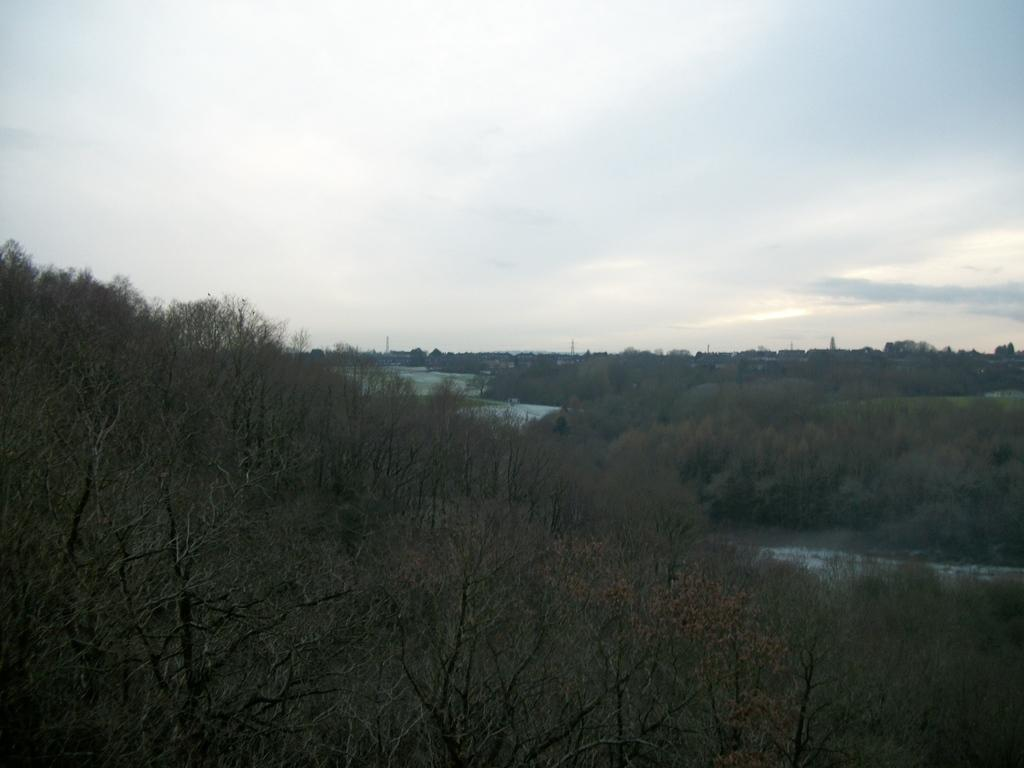What type of vegetation is present at the bottom of the image? There are trees at the bottom of the image. What part of the natural environment is visible at the top of the image? The sky is visible at the top of the image. How many pizzas are being tested in the image? There are no pizzas or any testing activity present in the image. What type of book can be seen on the tree in the image? There is no book present in the image; it features trees and the sky. 